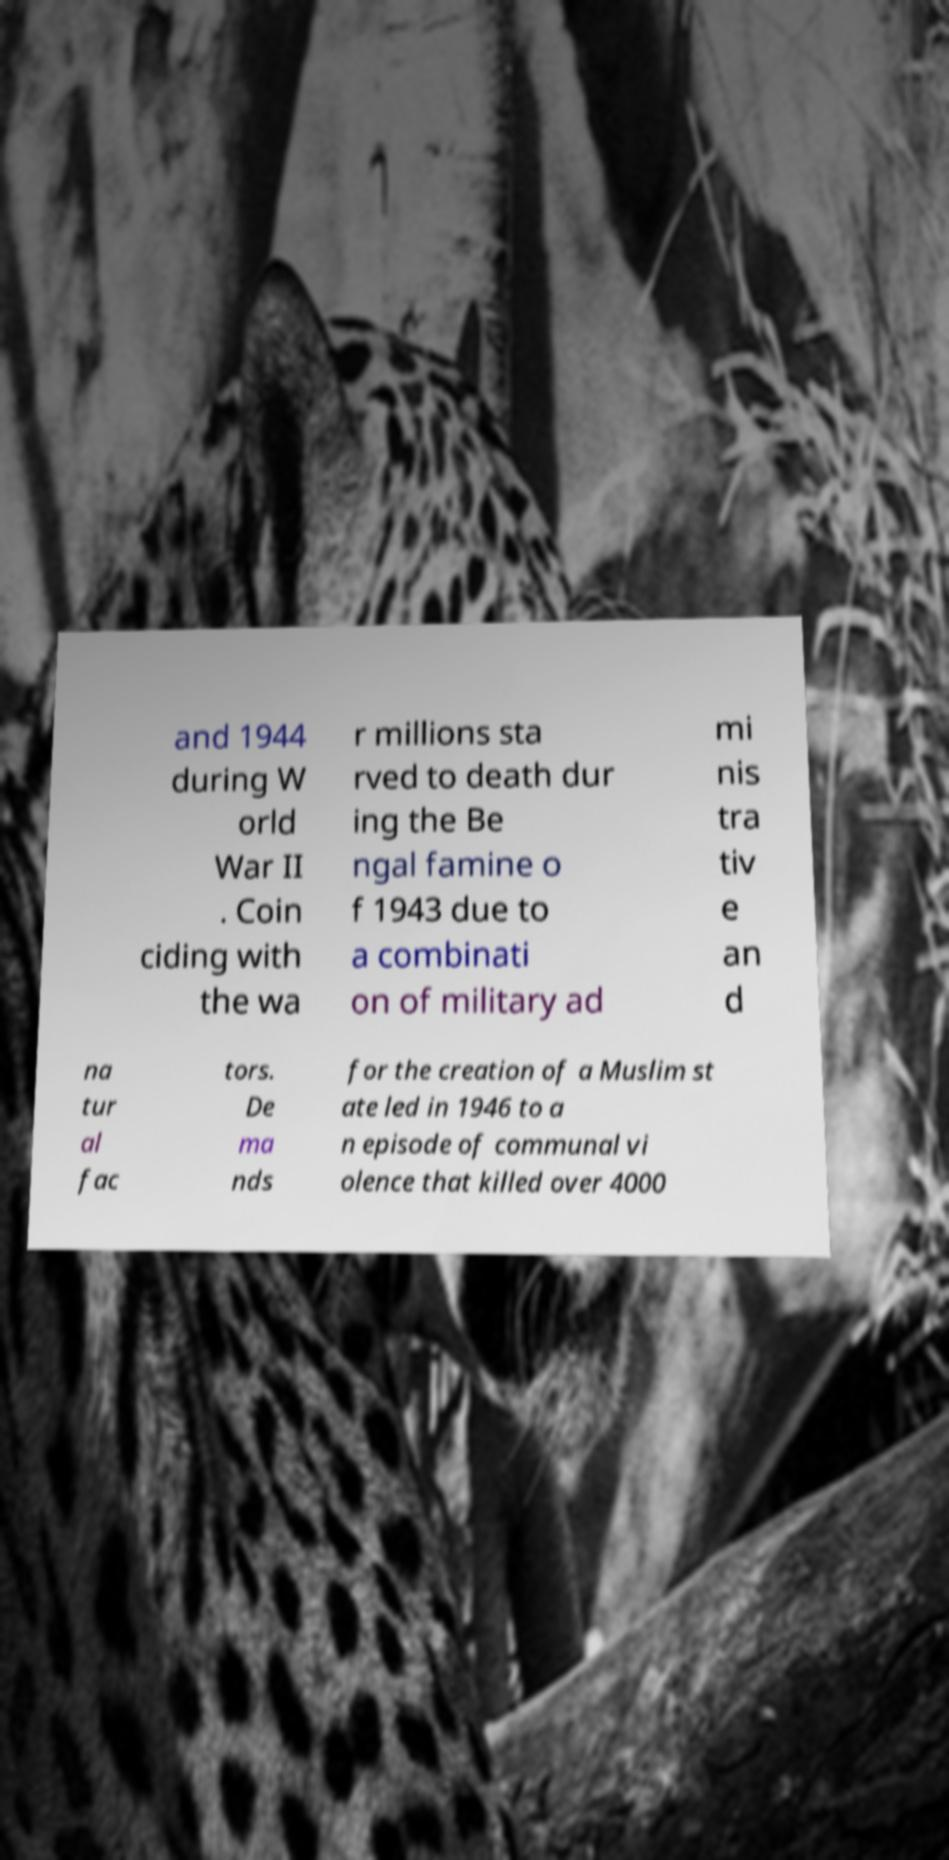For documentation purposes, I need the text within this image transcribed. Could you provide that? and 1944 during W orld War II . Coin ciding with the wa r millions sta rved to death dur ing the Be ngal famine o f 1943 due to a combinati on of military ad mi nis tra tiv e an d na tur al fac tors. De ma nds for the creation of a Muslim st ate led in 1946 to a n episode of communal vi olence that killed over 4000 